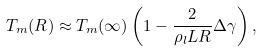<formula> <loc_0><loc_0><loc_500><loc_500>T _ { m } ( R ) \approx T _ { m } ( \infty ) \left ( 1 - \frac { 2 } { \rho _ { l } L R } \Delta \gamma \right ) ,</formula> 